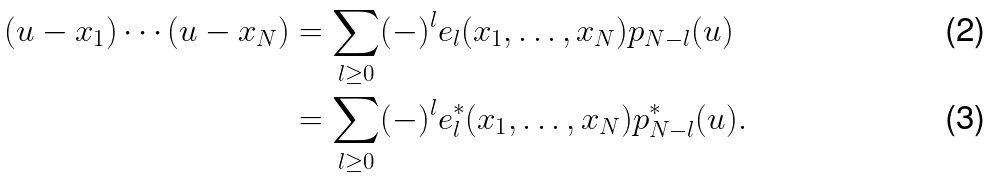Convert formula to latex. <formula><loc_0><loc_0><loc_500><loc_500>( u - x _ { 1 } ) \cdots ( u - x _ { N } ) & = \sum _ { l \geq 0 } ( - ) ^ { l } e _ { l } ( x _ { 1 } , \dots , x _ { N } ) p _ { N - l } ( u ) \\ & = \sum _ { l \geq 0 } ( - ) ^ { l } e ^ { * } _ { l } ( x _ { 1 } , \dots , x _ { N } ) p ^ { * } _ { N - l } ( u ) .</formula> 